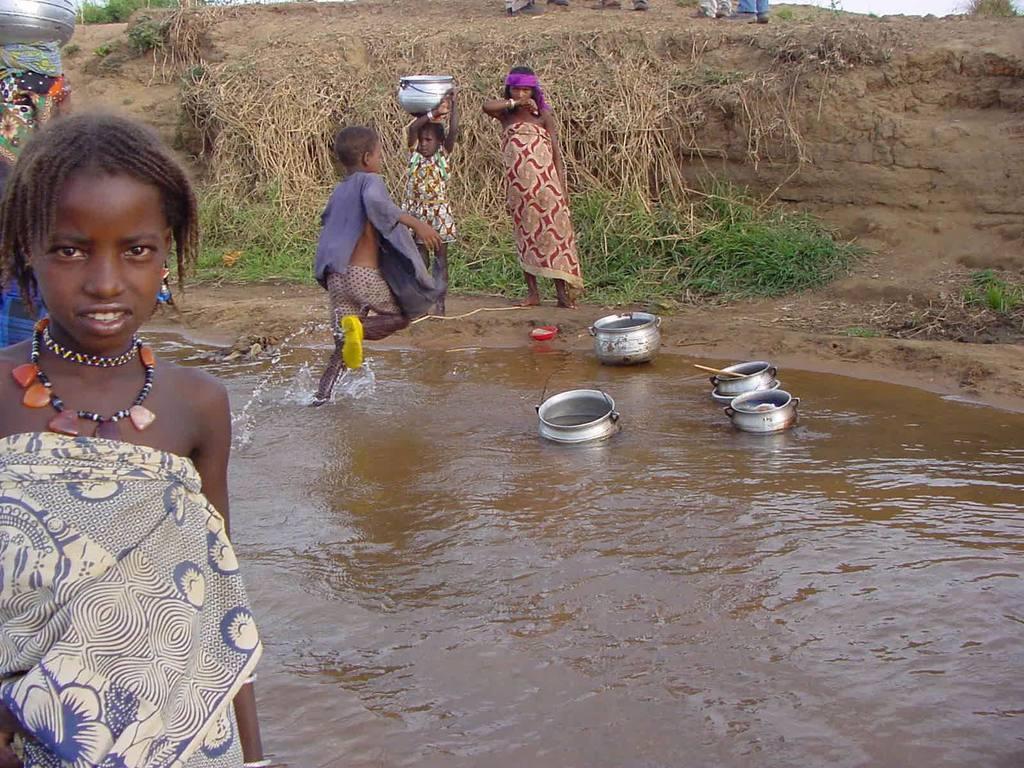Please provide a concise description of this image. In this image, I can see four persons standing. Among them two persons are holding the objects. There are utensils on the water. In the background, I can see the grass. 